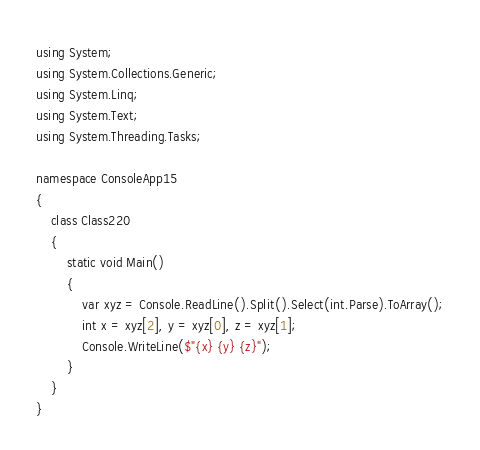<code> <loc_0><loc_0><loc_500><loc_500><_C#_>using System;
using System.Collections.Generic;
using System.Linq;
using System.Text;
using System.Threading.Tasks;

namespace ConsoleApp15
{
    class Class220
    {
        static void Main()
        {
            var xyz = Console.ReadLine().Split().Select(int.Parse).ToArray();
            int x = xyz[2], y = xyz[0], z = xyz[1];
            Console.WriteLine($"{x} {y} {z}");
        }
    }
}
</code> 